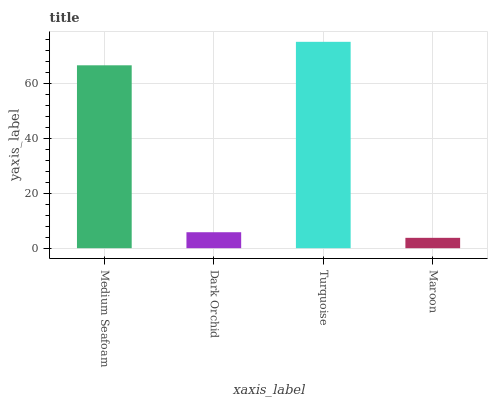Is Maroon the minimum?
Answer yes or no. Yes. Is Turquoise the maximum?
Answer yes or no. Yes. Is Dark Orchid the minimum?
Answer yes or no. No. Is Dark Orchid the maximum?
Answer yes or no. No. Is Medium Seafoam greater than Dark Orchid?
Answer yes or no. Yes. Is Dark Orchid less than Medium Seafoam?
Answer yes or no. Yes. Is Dark Orchid greater than Medium Seafoam?
Answer yes or no. No. Is Medium Seafoam less than Dark Orchid?
Answer yes or no. No. Is Medium Seafoam the high median?
Answer yes or no. Yes. Is Dark Orchid the low median?
Answer yes or no. Yes. Is Dark Orchid the high median?
Answer yes or no. No. Is Medium Seafoam the low median?
Answer yes or no. No. 